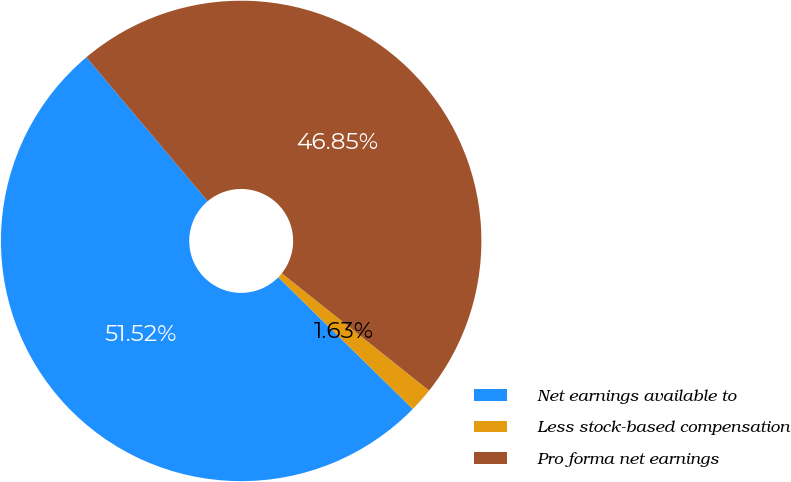Convert chart. <chart><loc_0><loc_0><loc_500><loc_500><pie_chart><fcel>Net earnings available to<fcel>Less stock-based compensation<fcel>Pro forma net earnings<nl><fcel>51.52%<fcel>1.63%<fcel>46.85%<nl></chart> 